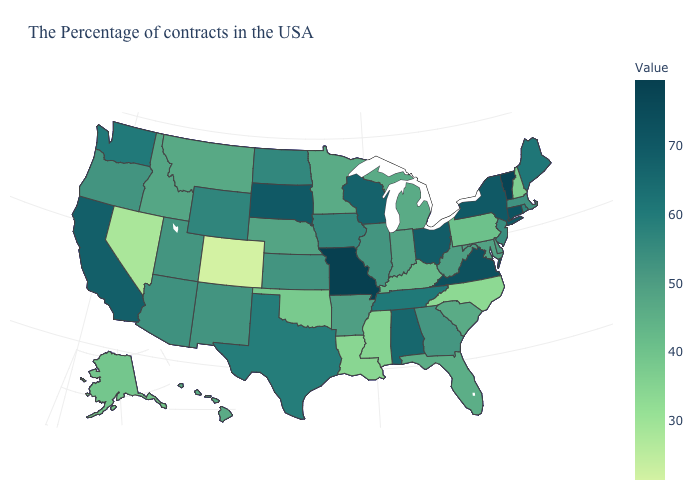Which states hav the highest value in the MidWest?
Quick response, please. Missouri. Among the states that border California , does Nevada have the lowest value?
Quick response, please. Yes. Does South Dakota have a lower value than Oklahoma?
Be succinct. No. Which states hav the highest value in the South?
Write a very short answer. Virginia. 